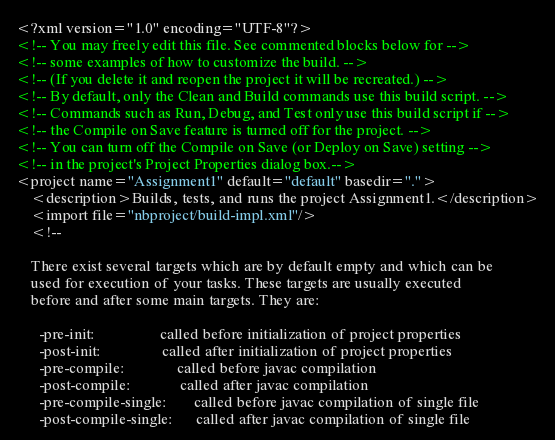Convert code to text. <code><loc_0><loc_0><loc_500><loc_500><_XML_><?xml version="1.0" encoding="UTF-8"?>
<!-- You may freely edit this file. See commented blocks below for -->
<!-- some examples of how to customize the build. -->
<!-- (If you delete it and reopen the project it will be recreated.) -->
<!-- By default, only the Clean and Build commands use this build script. -->
<!-- Commands such as Run, Debug, and Test only use this build script if -->
<!-- the Compile on Save feature is turned off for the project. -->
<!-- You can turn off the Compile on Save (or Deploy on Save) setting -->
<!-- in the project's Project Properties dialog box.-->
<project name="Assignment1" default="default" basedir=".">
    <description>Builds, tests, and runs the project Assignment1.</description>
    <import file="nbproject/build-impl.xml"/>
    <!--

    There exist several targets which are by default empty and which can be 
    used for execution of your tasks. These targets are usually executed 
    before and after some main targets. They are: 

      -pre-init:                 called before initialization of project properties
      -post-init:                called after initialization of project properties
      -pre-compile:              called before javac compilation
      -post-compile:             called after javac compilation
      -pre-compile-single:       called before javac compilation of single file
      -post-compile-single:      called after javac compilation of single file</code> 